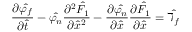<formula> <loc_0><loc_0><loc_500><loc_500>\frac { \partial \hat { \varphi _ { f } } } { \partial \hat { t } } - \hat { \varphi _ { n } } \frac { \partial ^ { 2 } \hat { F _ { 1 } } } { \partial \hat { x } ^ { 2 } } - \frac { \partial \hat { \varphi _ { n } } } { \partial \hat { x } } \frac { \partial \hat { F _ { 1 } } } { \partial \hat { x } } = \hat { \daleth _ { f } }</formula> 